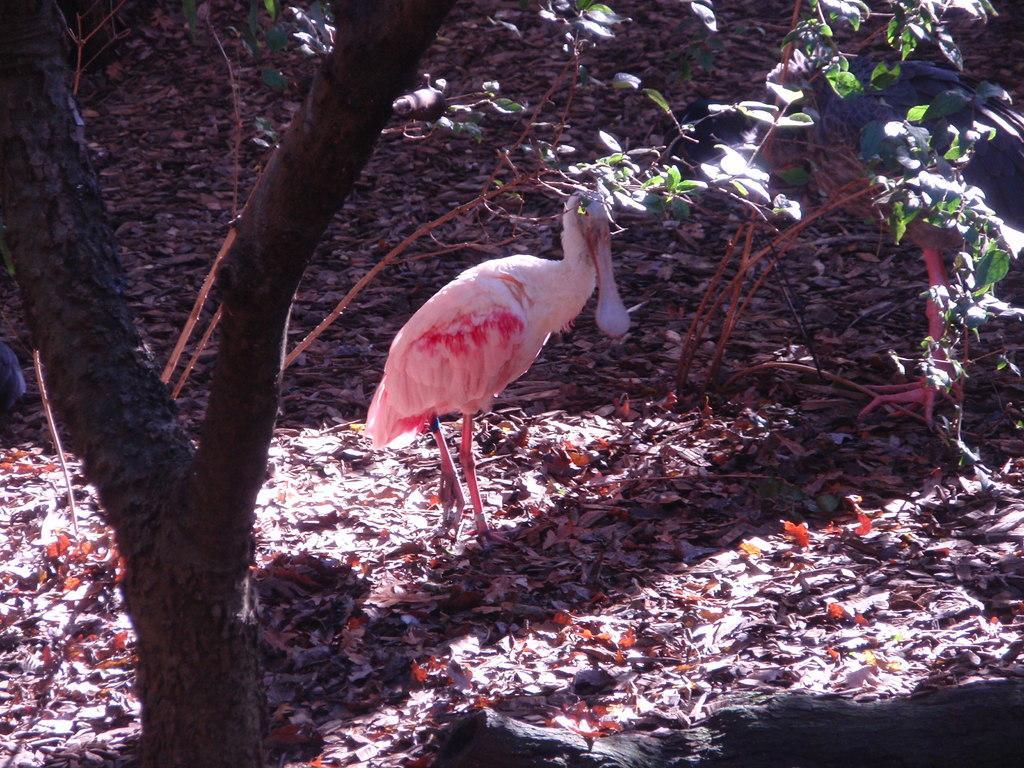How would you summarize this image in a sentence or two? In this image I can see a bird in white and pink color. I can see trees and few leaves. 